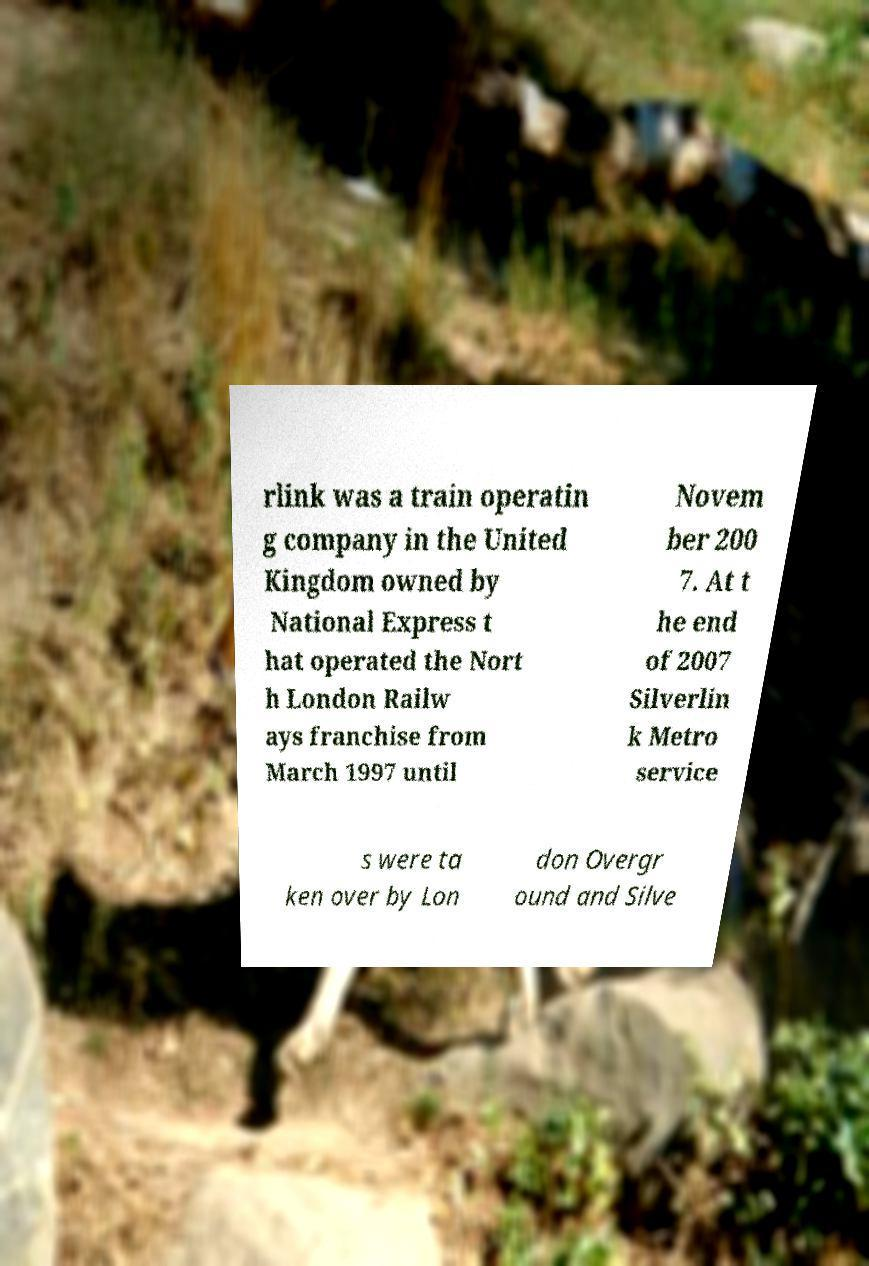Could you assist in decoding the text presented in this image and type it out clearly? rlink was a train operatin g company in the United Kingdom owned by National Express t hat operated the Nort h London Railw ays franchise from March 1997 until Novem ber 200 7. At t he end of 2007 Silverlin k Metro service s were ta ken over by Lon don Overgr ound and Silve 